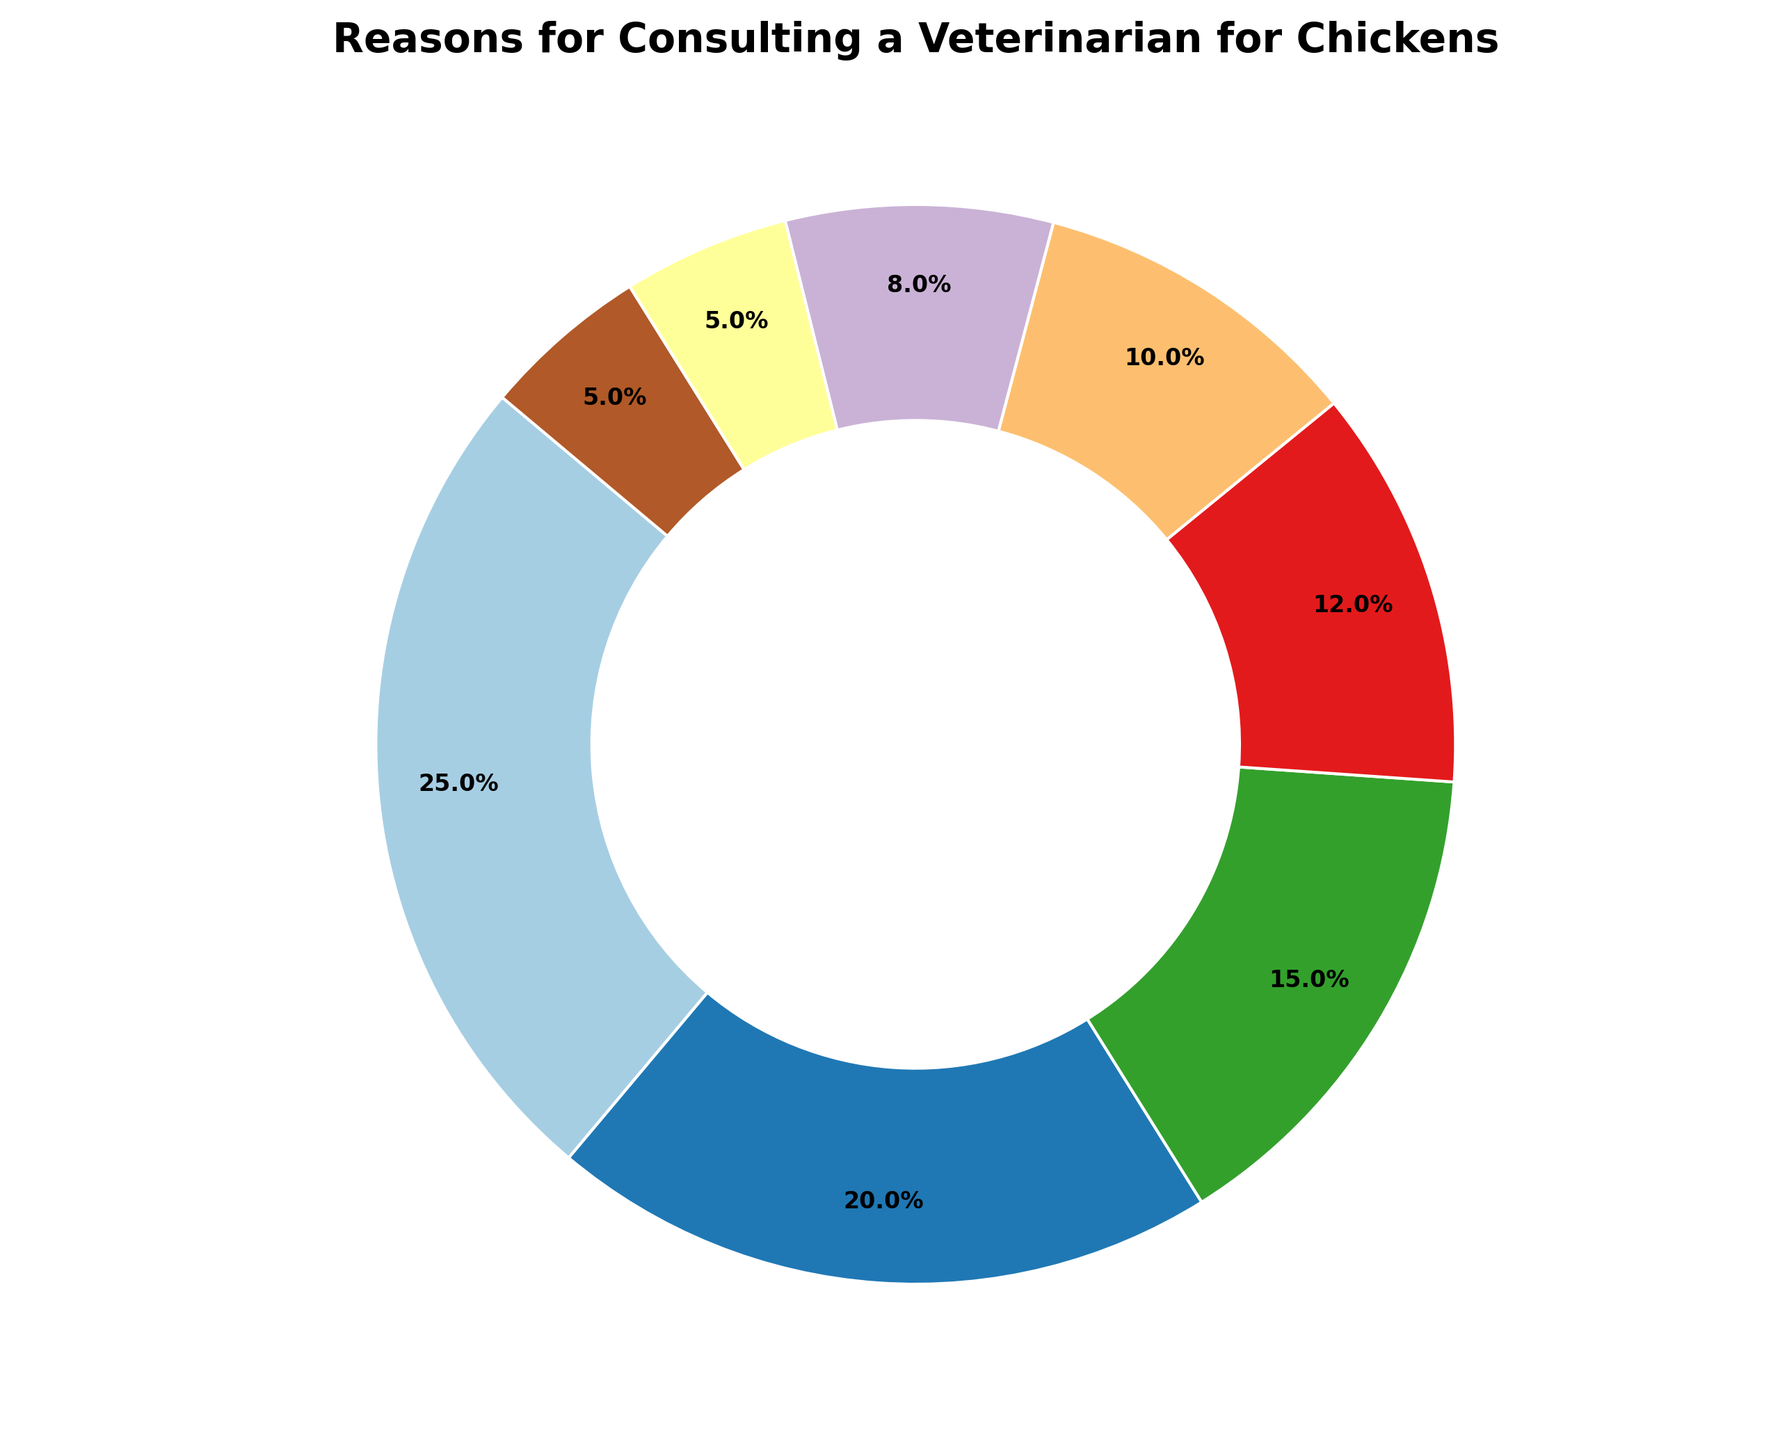Which reason accounts for the largest percentage of vet consultations? The largest percentage slice in the pie chart is for Respiratory Issues, which makes up 25% of the reasons for consulting a veterinarian.
Answer: Respiratory Issues Which two categories combined make up the smallest percentage of vet consultations? The two smallest slices in the pie chart are Infectious Diseases and Other, each with 5%. When combined, these reasons make up 10% of the vet consultations.
Answer: Infectious Diseases and Other How much larger is the percentage of Respiratory Issues compared to that of Nutritional Concerns? Respiratory Issues account for 25% of the visits, whereas Nutritional Concerns account for 10%. The difference is 25% - 10% = 15%.
Answer: 15% Which reasons for veterinary consultation make up more than half of the total percentage? The reasons need to sum up to more than 50%. Respiratory Issues (25%) + Parasites (20%) = 45%. Adding Egg Laying Problems (15%) gives a total of 60%.
Answer: Respiratory Issues, Parasites, Egg Laying Problems What is the total percentage for Behavioral Issues, Nutritional Concerns, and Injuries combined? To find the total, Sum the percentages: Behavioral Issues (8%) + Nutritional Concerns (10%) + Injuries (12%) = 8 + 10 + 12 = 30%
Answer: 30% Which categories, based on their visual sizes, seem roughly equal in percentage? Infectious Diseases and Other both visually occupy small and roughly equal areas of the pie chart, each accounting for 5%.
Answer: Infectious Diseases and Other Are there more consultations for Injuries or Nutritional Concerns, and by how much? Injuries make up 12% while Nutritional Concerns make up 10%. The difference is 12% - 10% = 2%.
Answer: Injuries, by 2% Rank the reasons for consulting a veterinarian from most to least common. Order by percentage: 1. Respiratory Issues (25%), 2. Parasites (20%), 3. Egg Laying Problems (15%), 4. Injuries (12%), 5. Nutritional Concerns (10%), 6. Behavioral Issues (8%), 7. Infectious Diseases (5%), 8. Other (5%).
Answer: Respiratory Issues, Parasites, Egg Laying Problems, Injuries, Nutritional Concerns, Behavioral Issues, Infectious Diseases, Other 